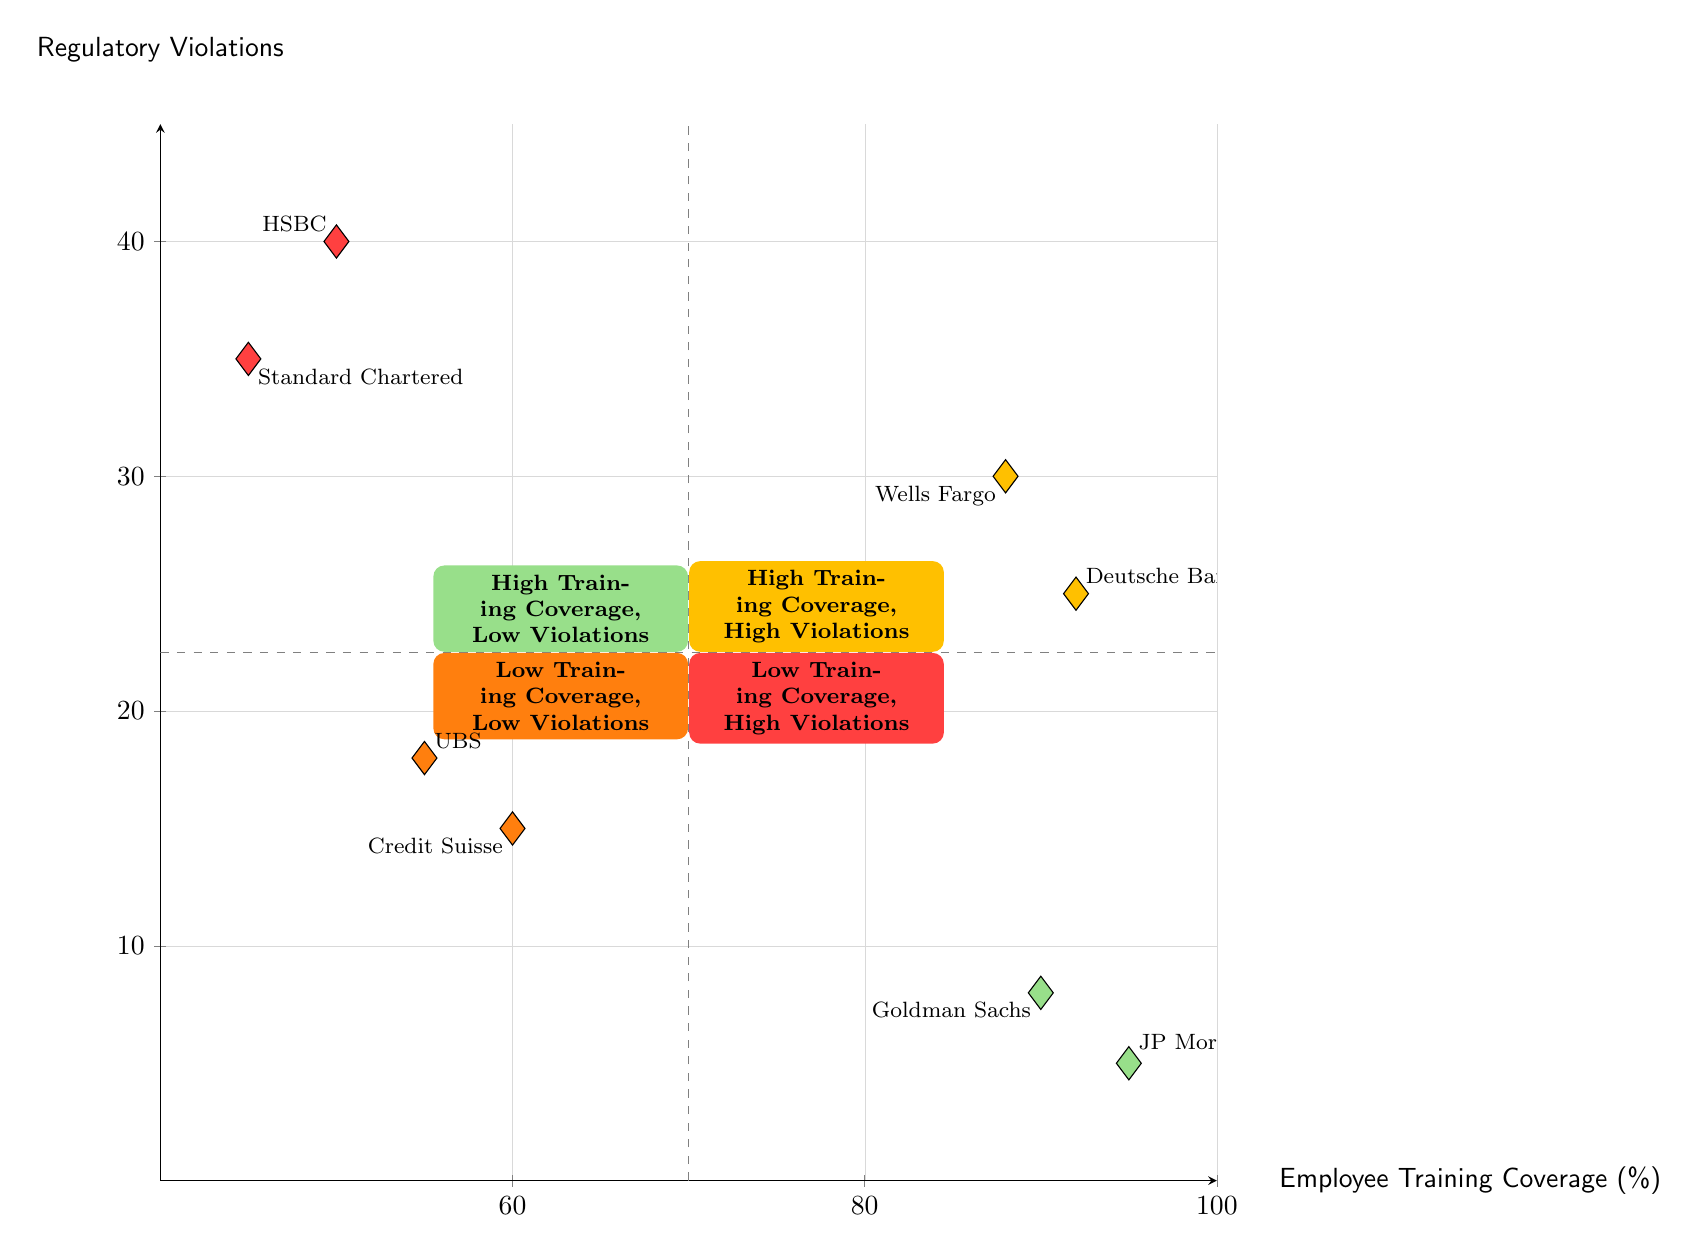What is the training coverage percentage of JP Morgan Chase? The diagram shows a data point for JP Morgan Chase, placed at 95% on the x-axis, which indicates its training coverage percentage.
Answer: 95% How many regulatory violations does Goldman Sachs have? Looking at the data point for Goldman Sachs on the diagram, it is located at 8 on the y-axis, representing the number of regulatory violations.
Answer: 8 Which institution shows high training coverage but also high regulatory violations? In the upper right quadrant, specifically labeled "High Training Coverage, High Violations," Deutsche Bank and Wells Fargo are shown, demonstrating a relationship of high training coverage and simultaneously high violations.
Answer: Deutsche Bank and Wells Fargo What is the maximum number of regulatory violations recorded for low training coverage institutions? By examining the "Low Training Coverage, High Violations" quadrant, the institutions HSBC and Standard Chartered have violations of 40 and 35, respectively. Therefore, the maximum is 40.
Answer: 40 How many institutions have low training coverage and low violations? The bottom left quadrant "Low Training Coverage, Low Violations" contains two institutions: Credit Suisse and UBS, which means there are a total of two institutions in that category.
Answer: Two Which quadrant contains the most regulatory violations? To determine the quadrant with the most regulatory violations, each quadrant's maximum violation count is examined. The "Low Training Coverage, High Violations" quadrant has HSBC with 40 violations, which is the highest counted.
Answer: Low Training Coverage, High Violations How much training coverage percentage does HSBC have? Referring to the data point for HSBC located in the "Low Training Coverage, High Violations" quadrant, it shows a training coverage percentage of 50% indicated on the x-axis.
Answer: 50% How many violations does UBS have compared to Credit Suisse? The number of violations for UBS is 18, and for Credit Suisse, it is 15. Therefore, UBS has 3 more violations than Credit Suisse.
Answer: UBS has 3 more violations than Credit Suisse What color represents the "High Training Coverage, Low Violations" quadrant? The quadrant labeled "High Training Coverage, Low Violations" is colored light green in the diagram, signifying its designation among the quadrants with that specific axis positioning.
Answer: Light green 